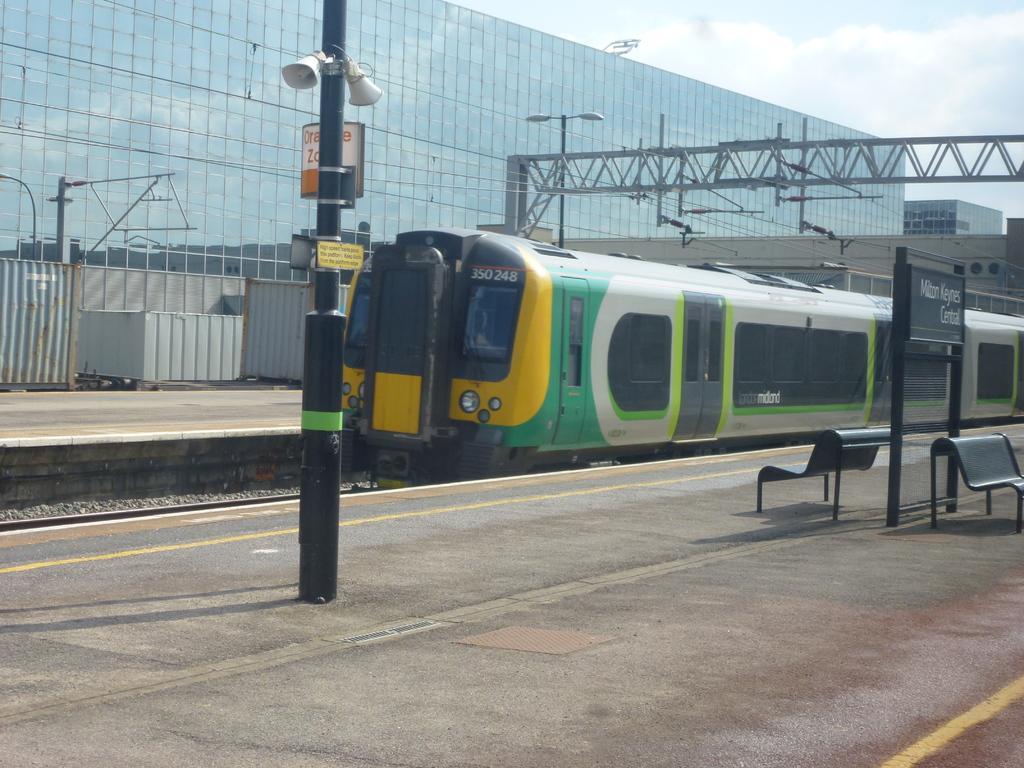In one or two sentences, can you explain what this image depicts? In this image in the center there is a train, at the bottom there is a railway track and a walkway and also we could see some poles. On the pole there is a board and some speakers, on the right side there are two benches and some board. On the board there is some text. In the background there are some buildings, towers and at the top of the image there is sky. 